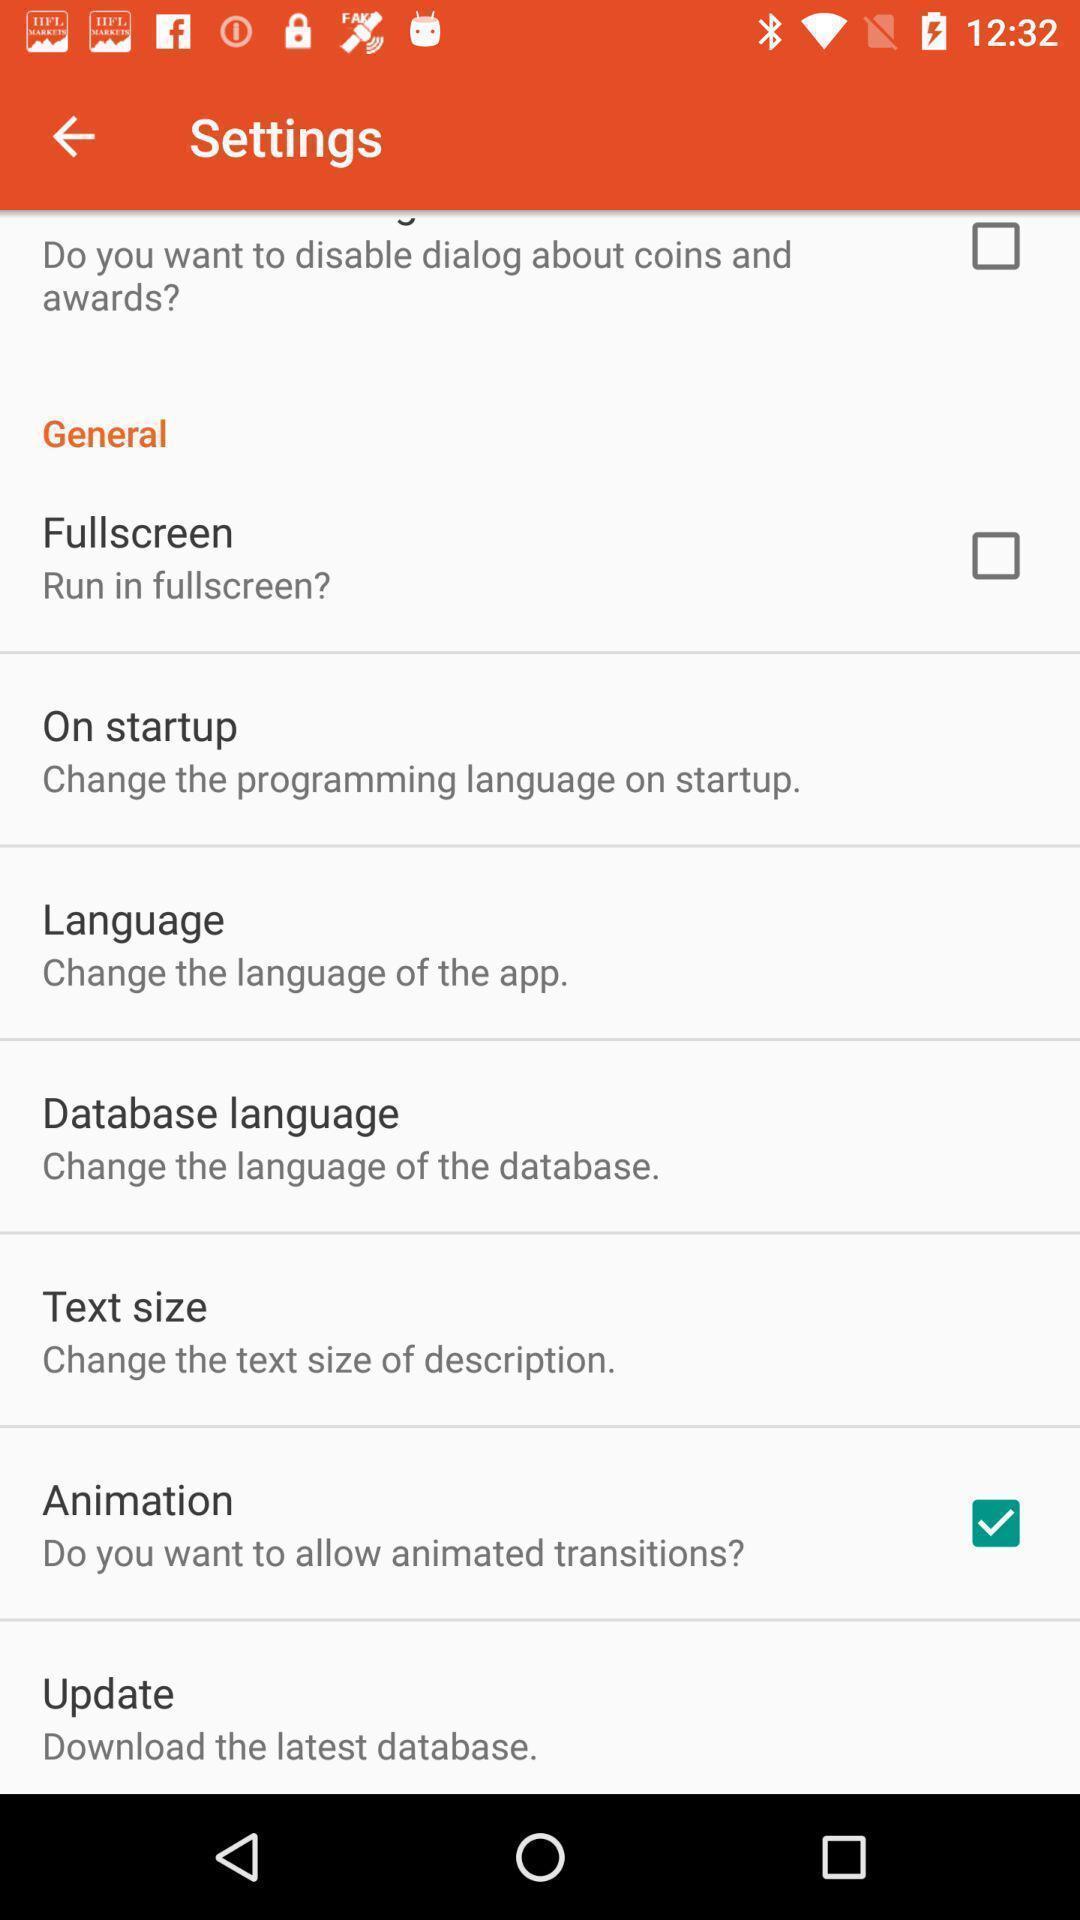Tell me what you see in this picture. Setting page displaying the various options. 